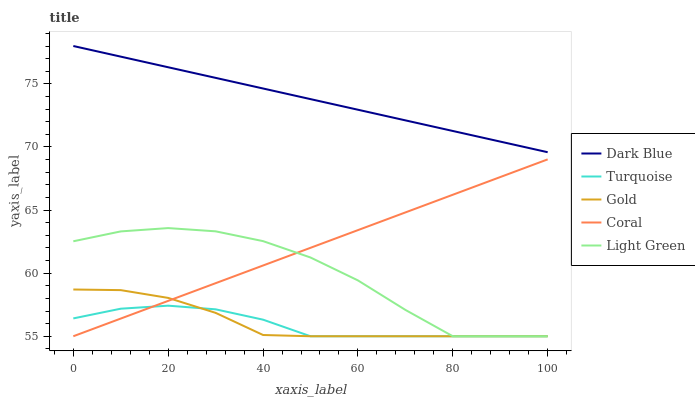Does Turquoise have the minimum area under the curve?
Answer yes or no. Yes. Does Dark Blue have the maximum area under the curve?
Answer yes or no. Yes. Does Light Green have the minimum area under the curve?
Answer yes or no. No. Does Light Green have the maximum area under the curve?
Answer yes or no. No. Is Dark Blue the smoothest?
Answer yes or no. Yes. Is Light Green the roughest?
Answer yes or no. Yes. Is Turquoise the smoothest?
Answer yes or no. No. Is Turquoise the roughest?
Answer yes or no. No. Does Turquoise have the lowest value?
Answer yes or no. Yes. Does Dark Blue have the highest value?
Answer yes or no. Yes. Does Light Green have the highest value?
Answer yes or no. No. Is Coral less than Dark Blue?
Answer yes or no. Yes. Is Dark Blue greater than Coral?
Answer yes or no. Yes. Does Coral intersect Gold?
Answer yes or no. Yes. Is Coral less than Gold?
Answer yes or no. No. Is Coral greater than Gold?
Answer yes or no. No. Does Coral intersect Dark Blue?
Answer yes or no. No. 